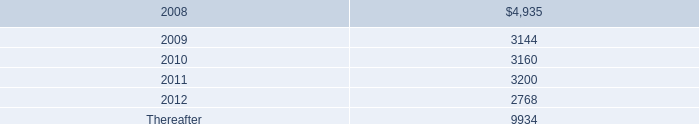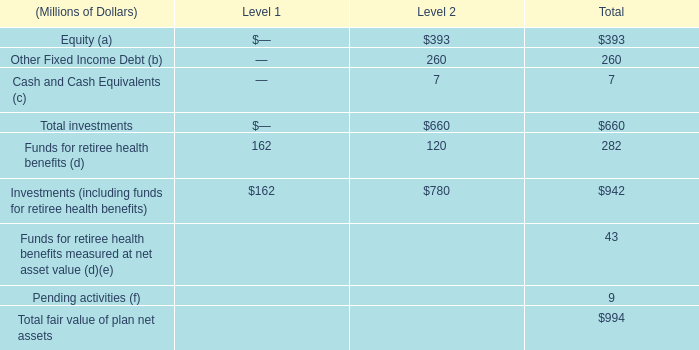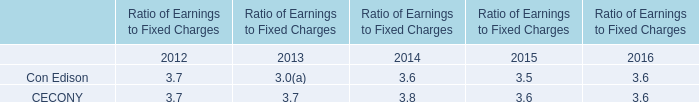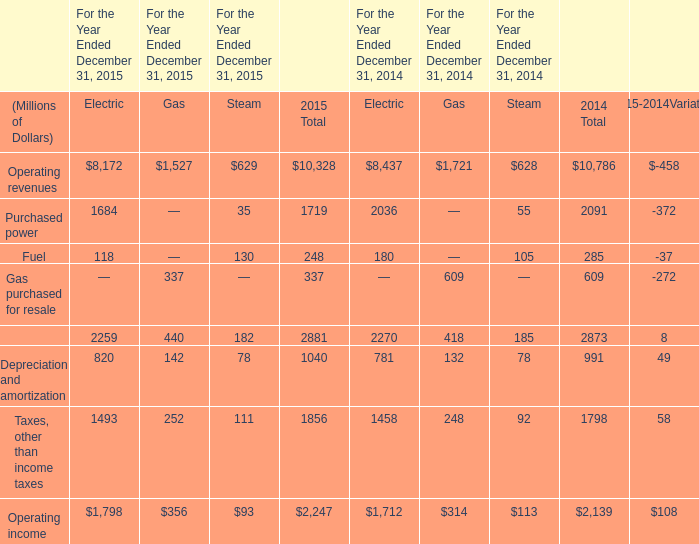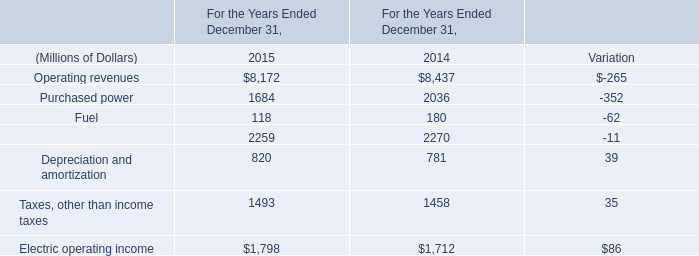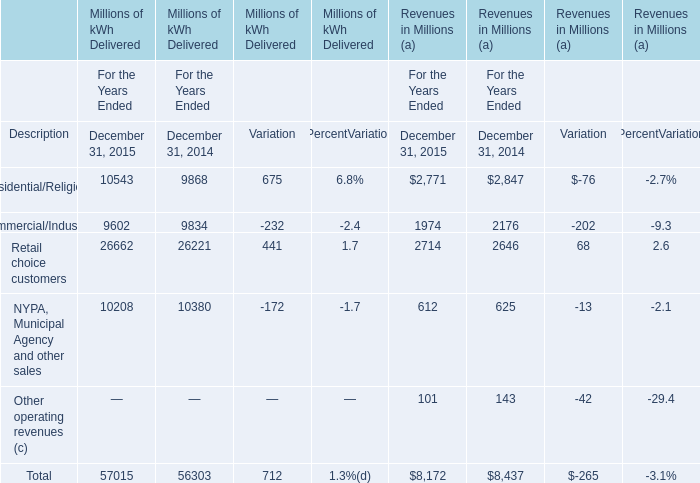What's the growth rate of Total of Millions of kWh Delivered in 2015? 
Computations: ((57015 - 56303) / 56303)
Answer: 0.01265. 